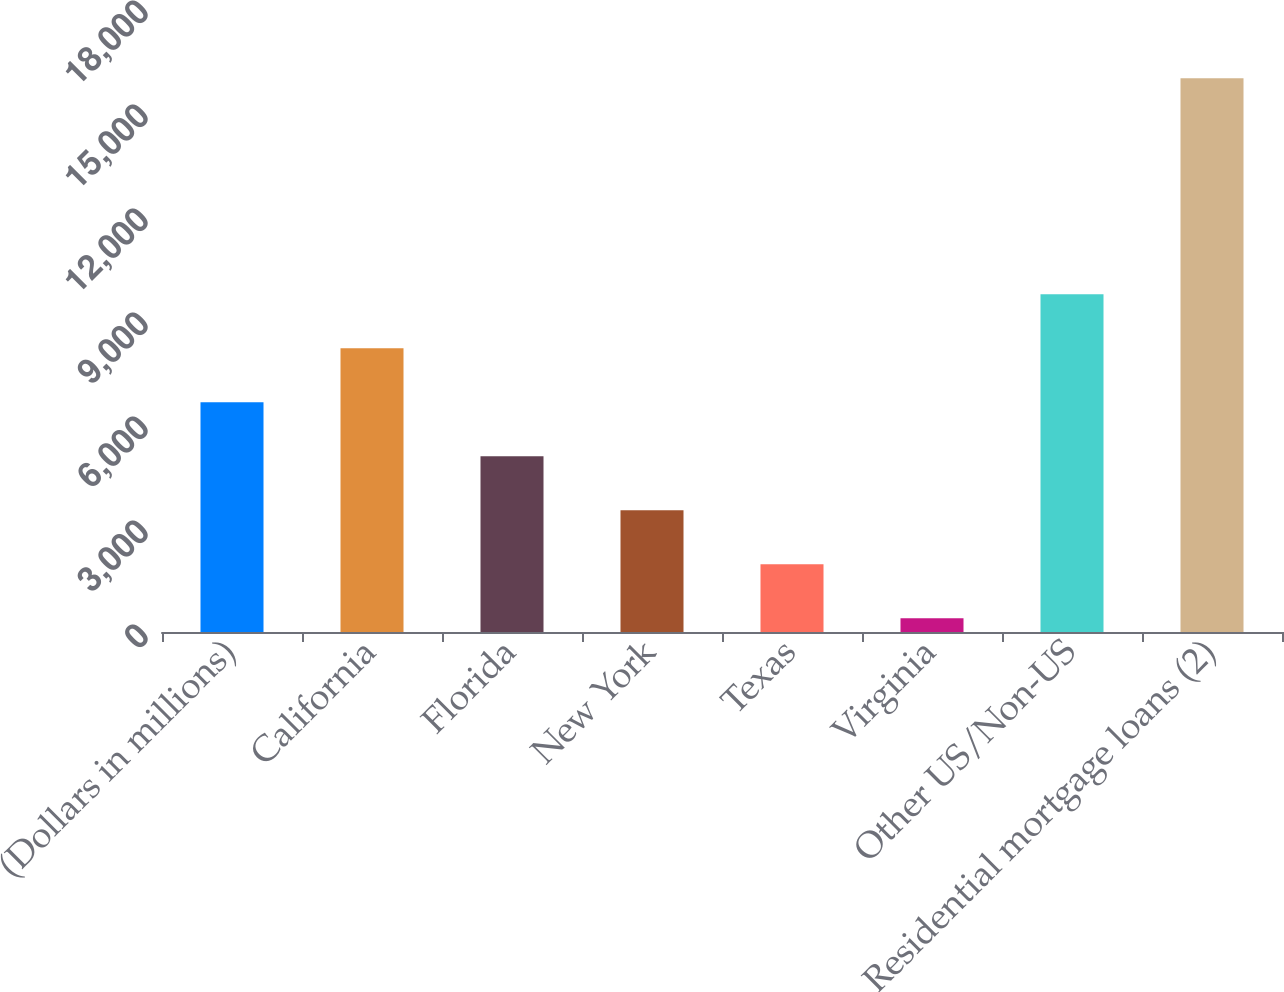Convert chart. <chart><loc_0><loc_0><loc_500><loc_500><bar_chart><fcel>(Dollars in millions)<fcel>California<fcel>Florida<fcel>New York<fcel>Texas<fcel>Virginia<fcel>Other US/Non-US<fcel>Residential mortgage loans (2)<nl><fcel>6627.4<fcel>8184.5<fcel>5070.3<fcel>3513.2<fcel>1956.1<fcel>399<fcel>9741.6<fcel>15970<nl></chart> 